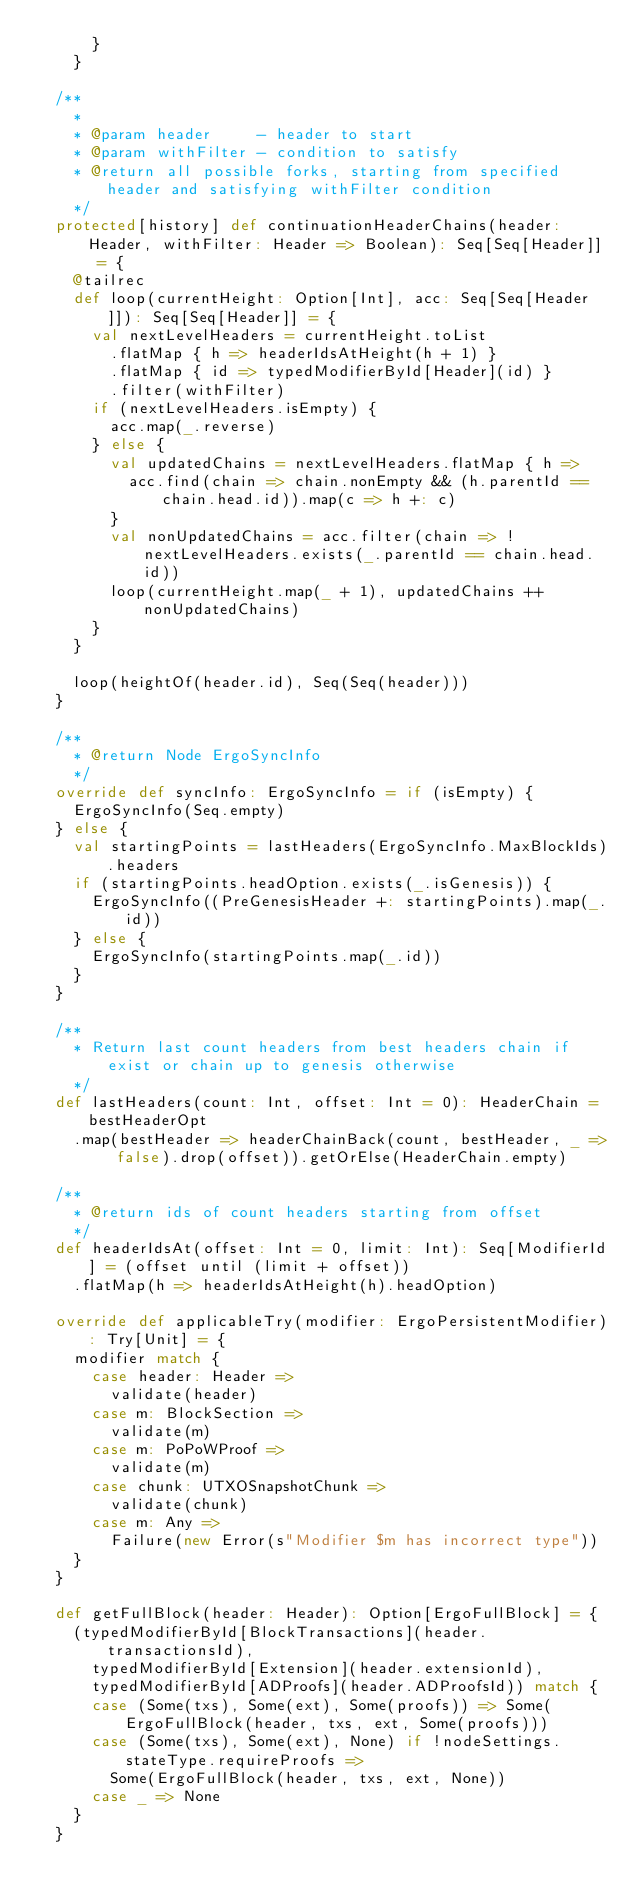Convert code to text. <code><loc_0><loc_0><loc_500><loc_500><_Scala_>      }
    }

  /**
    *
    * @param header     - header to start
    * @param withFilter - condition to satisfy
    * @return all possible forks, starting from specified header and satisfying withFilter condition
    */
  protected[history] def continuationHeaderChains(header: Header, withFilter: Header => Boolean): Seq[Seq[Header]] = {
    @tailrec
    def loop(currentHeight: Option[Int], acc: Seq[Seq[Header]]): Seq[Seq[Header]] = {
      val nextLevelHeaders = currentHeight.toList
        .flatMap { h => headerIdsAtHeight(h + 1) }
        .flatMap { id => typedModifierById[Header](id) }
        .filter(withFilter)
      if (nextLevelHeaders.isEmpty) {
        acc.map(_.reverse)
      } else {
        val updatedChains = nextLevelHeaders.flatMap { h =>
          acc.find(chain => chain.nonEmpty && (h.parentId == chain.head.id)).map(c => h +: c)
        }
        val nonUpdatedChains = acc.filter(chain => !nextLevelHeaders.exists(_.parentId == chain.head.id))
        loop(currentHeight.map(_ + 1), updatedChains ++ nonUpdatedChains)
      }
    }

    loop(heightOf(header.id), Seq(Seq(header)))
  }

  /**
    * @return Node ErgoSyncInfo
    */
  override def syncInfo: ErgoSyncInfo = if (isEmpty) {
    ErgoSyncInfo(Seq.empty)
  } else {
    val startingPoints = lastHeaders(ErgoSyncInfo.MaxBlockIds).headers
    if (startingPoints.headOption.exists(_.isGenesis)) {
      ErgoSyncInfo((PreGenesisHeader +: startingPoints).map(_.id))
    } else {
      ErgoSyncInfo(startingPoints.map(_.id))
    }
  }

  /**
    * Return last count headers from best headers chain if exist or chain up to genesis otherwise
    */
  def lastHeaders(count: Int, offset: Int = 0): HeaderChain = bestHeaderOpt
    .map(bestHeader => headerChainBack(count, bestHeader, _ => false).drop(offset)).getOrElse(HeaderChain.empty)

  /**
    * @return ids of count headers starting from offset
    */
  def headerIdsAt(offset: Int = 0, limit: Int): Seq[ModifierId] = (offset until (limit + offset))
    .flatMap(h => headerIdsAtHeight(h).headOption)

  override def applicableTry(modifier: ErgoPersistentModifier): Try[Unit] = {
    modifier match {
      case header: Header =>
        validate(header)
      case m: BlockSection =>
        validate(m)
      case m: PoPoWProof =>
        validate(m)
      case chunk: UTXOSnapshotChunk =>
        validate(chunk)
      case m: Any =>
        Failure(new Error(s"Modifier $m has incorrect type"))
    }
  }

  def getFullBlock(header: Header): Option[ErgoFullBlock] = {
    (typedModifierById[BlockTransactions](header.transactionsId),
      typedModifierById[Extension](header.extensionId),
      typedModifierById[ADProofs](header.ADProofsId)) match {
      case (Some(txs), Some(ext), Some(proofs)) => Some(ErgoFullBlock(header, txs, ext, Some(proofs)))
      case (Some(txs), Some(ext), None) if !nodeSettings.stateType.requireProofs =>
        Some(ErgoFullBlock(header, txs, ext, None))
      case _ => None
    }
  }
</code> 